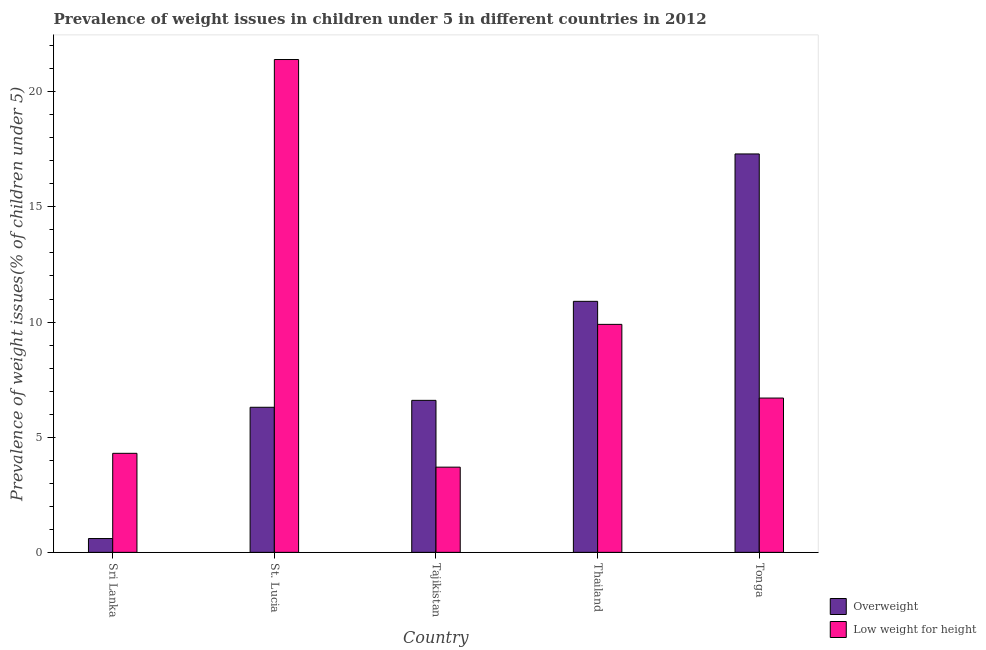Are the number of bars per tick equal to the number of legend labels?
Provide a succinct answer. Yes. Are the number of bars on each tick of the X-axis equal?
Ensure brevity in your answer.  Yes. How many bars are there on the 2nd tick from the right?
Provide a short and direct response. 2. What is the label of the 3rd group of bars from the left?
Your response must be concise. Tajikistan. In how many cases, is the number of bars for a given country not equal to the number of legend labels?
Keep it short and to the point. 0. What is the percentage of underweight children in St. Lucia?
Your response must be concise. 21.4. Across all countries, what is the maximum percentage of underweight children?
Provide a succinct answer. 21.4. Across all countries, what is the minimum percentage of overweight children?
Your answer should be compact. 0.6. In which country was the percentage of overweight children maximum?
Give a very brief answer. Tonga. In which country was the percentage of underweight children minimum?
Make the answer very short. Tajikistan. What is the total percentage of overweight children in the graph?
Make the answer very short. 41.7. What is the difference between the percentage of underweight children in Tajikistan and that in Thailand?
Offer a very short reply. -6.2. What is the difference between the percentage of overweight children in Tajikistan and the percentage of underweight children in Tonga?
Offer a terse response. -0.1. What is the average percentage of underweight children per country?
Your answer should be very brief. 9.2. What is the difference between the percentage of underweight children and percentage of overweight children in St. Lucia?
Give a very brief answer. 15.1. What is the ratio of the percentage of overweight children in St. Lucia to that in Tonga?
Your answer should be very brief. 0.36. Is the percentage of overweight children in Tajikistan less than that in Tonga?
Provide a succinct answer. Yes. What is the difference between the highest and the second highest percentage of overweight children?
Offer a terse response. 6.4. What is the difference between the highest and the lowest percentage of overweight children?
Keep it short and to the point. 16.7. In how many countries, is the percentage of underweight children greater than the average percentage of underweight children taken over all countries?
Offer a terse response. 2. What does the 1st bar from the left in St. Lucia represents?
Offer a terse response. Overweight. What does the 2nd bar from the right in Sri Lanka represents?
Give a very brief answer. Overweight. Are all the bars in the graph horizontal?
Your answer should be very brief. No. How many countries are there in the graph?
Provide a short and direct response. 5. What is the difference between two consecutive major ticks on the Y-axis?
Your answer should be very brief. 5. Are the values on the major ticks of Y-axis written in scientific E-notation?
Give a very brief answer. No. Does the graph contain grids?
Offer a terse response. No. How are the legend labels stacked?
Make the answer very short. Vertical. What is the title of the graph?
Your answer should be very brief. Prevalence of weight issues in children under 5 in different countries in 2012. What is the label or title of the Y-axis?
Make the answer very short. Prevalence of weight issues(% of children under 5). What is the Prevalence of weight issues(% of children under 5) of Overweight in Sri Lanka?
Keep it short and to the point. 0.6. What is the Prevalence of weight issues(% of children under 5) of Low weight for height in Sri Lanka?
Make the answer very short. 4.3. What is the Prevalence of weight issues(% of children under 5) of Overweight in St. Lucia?
Offer a terse response. 6.3. What is the Prevalence of weight issues(% of children under 5) in Low weight for height in St. Lucia?
Ensure brevity in your answer.  21.4. What is the Prevalence of weight issues(% of children under 5) in Overweight in Tajikistan?
Offer a terse response. 6.6. What is the Prevalence of weight issues(% of children under 5) of Low weight for height in Tajikistan?
Make the answer very short. 3.7. What is the Prevalence of weight issues(% of children under 5) of Overweight in Thailand?
Your answer should be compact. 10.9. What is the Prevalence of weight issues(% of children under 5) in Low weight for height in Thailand?
Give a very brief answer. 9.9. What is the Prevalence of weight issues(% of children under 5) in Overweight in Tonga?
Offer a terse response. 17.3. What is the Prevalence of weight issues(% of children under 5) in Low weight for height in Tonga?
Offer a very short reply. 6.7. Across all countries, what is the maximum Prevalence of weight issues(% of children under 5) in Overweight?
Your answer should be very brief. 17.3. Across all countries, what is the maximum Prevalence of weight issues(% of children under 5) of Low weight for height?
Your answer should be compact. 21.4. Across all countries, what is the minimum Prevalence of weight issues(% of children under 5) in Overweight?
Provide a short and direct response. 0.6. Across all countries, what is the minimum Prevalence of weight issues(% of children under 5) in Low weight for height?
Offer a terse response. 3.7. What is the total Prevalence of weight issues(% of children under 5) in Overweight in the graph?
Give a very brief answer. 41.7. What is the difference between the Prevalence of weight issues(% of children under 5) in Overweight in Sri Lanka and that in St. Lucia?
Offer a very short reply. -5.7. What is the difference between the Prevalence of weight issues(% of children under 5) of Low weight for height in Sri Lanka and that in St. Lucia?
Offer a very short reply. -17.1. What is the difference between the Prevalence of weight issues(% of children under 5) in Overweight in Sri Lanka and that in Tajikistan?
Give a very brief answer. -6. What is the difference between the Prevalence of weight issues(% of children under 5) in Low weight for height in Sri Lanka and that in Tajikistan?
Offer a terse response. 0.6. What is the difference between the Prevalence of weight issues(% of children under 5) of Overweight in Sri Lanka and that in Tonga?
Your answer should be compact. -16.7. What is the difference between the Prevalence of weight issues(% of children under 5) in Low weight for height in St. Lucia and that in Tajikistan?
Offer a very short reply. 17.7. What is the difference between the Prevalence of weight issues(% of children under 5) in Overweight in Tajikistan and that in Thailand?
Offer a very short reply. -4.3. What is the difference between the Prevalence of weight issues(% of children under 5) of Low weight for height in Thailand and that in Tonga?
Your response must be concise. 3.2. What is the difference between the Prevalence of weight issues(% of children under 5) of Overweight in Sri Lanka and the Prevalence of weight issues(% of children under 5) of Low weight for height in St. Lucia?
Make the answer very short. -20.8. What is the difference between the Prevalence of weight issues(% of children under 5) in Overweight in Sri Lanka and the Prevalence of weight issues(% of children under 5) in Low weight for height in Thailand?
Your answer should be very brief. -9.3. What is the difference between the Prevalence of weight issues(% of children under 5) of Overweight in St. Lucia and the Prevalence of weight issues(% of children under 5) of Low weight for height in Thailand?
Provide a short and direct response. -3.6. What is the difference between the Prevalence of weight issues(% of children under 5) of Overweight in Tajikistan and the Prevalence of weight issues(% of children under 5) of Low weight for height in Thailand?
Offer a terse response. -3.3. What is the difference between the Prevalence of weight issues(% of children under 5) of Overweight in Thailand and the Prevalence of weight issues(% of children under 5) of Low weight for height in Tonga?
Provide a succinct answer. 4.2. What is the average Prevalence of weight issues(% of children under 5) in Overweight per country?
Your response must be concise. 8.34. What is the difference between the Prevalence of weight issues(% of children under 5) in Overweight and Prevalence of weight issues(% of children under 5) in Low weight for height in St. Lucia?
Give a very brief answer. -15.1. What is the difference between the Prevalence of weight issues(% of children under 5) of Overweight and Prevalence of weight issues(% of children under 5) of Low weight for height in Thailand?
Offer a very short reply. 1. What is the difference between the Prevalence of weight issues(% of children under 5) of Overweight and Prevalence of weight issues(% of children under 5) of Low weight for height in Tonga?
Your answer should be compact. 10.6. What is the ratio of the Prevalence of weight issues(% of children under 5) in Overweight in Sri Lanka to that in St. Lucia?
Make the answer very short. 0.1. What is the ratio of the Prevalence of weight issues(% of children under 5) in Low weight for height in Sri Lanka to that in St. Lucia?
Offer a terse response. 0.2. What is the ratio of the Prevalence of weight issues(% of children under 5) of Overweight in Sri Lanka to that in Tajikistan?
Provide a succinct answer. 0.09. What is the ratio of the Prevalence of weight issues(% of children under 5) of Low weight for height in Sri Lanka to that in Tajikistan?
Provide a short and direct response. 1.16. What is the ratio of the Prevalence of weight issues(% of children under 5) of Overweight in Sri Lanka to that in Thailand?
Your response must be concise. 0.06. What is the ratio of the Prevalence of weight issues(% of children under 5) of Low weight for height in Sri Lanka to that in Thailand?
Offer a terse response. 0.43. What is the ratio of the Prevalence of weight issues(% of children under 5) in Overweight in Sri Lanka to that in Tonga?
Provide a succinct answer. 0.03. What is the ratio of the Prevalence of weight issues(% of children under 5) of Low weight for height in Sri Lanka to that in Tonga?
Ensure brevity in your answer.  0.64. What is the ratio of the Prevalence of weight issues(% of children under 5) in Overweight in St. Lucia to that in Tajikistan?
Provide a succinct answer. 0.95. What is the ratio of the Prevalence of weight issues(% of children under 5) of Low weight for height in St. Lucia to that in Tajikistan?
Offer a terse response. 5.78. What is the ratio of the Prevalence of weight issues(% of children under 5) of Overweight in St. Lucia to that in Thailand?
Keep it short and to the point. 0.58. What is the ratio of the Prevalence of weight issues(% of children under 5) of Low weight for height in St. Lucia to that in Thailand?
Your response must be concise. 2.16. What is the ratio of the Prevalence of weight issues(% of children under 5) of Overweight in St. Lucia to that in Tonga?
Make the answer very short. 0.36. What is the ratio of the Prevalence of weight issues(% of children under 5) in Low weight for height in St. Lucia to that in Tonga?
Provide a succinct answer. 3.19. What is the ratio of the Prevalence of weight issues(% of children under 5) of Overweight in Tajikistan to that in Thailand?
Provide a succinct answer. 0.61. What is the ratio of the Prevalence of weight issues(% of children under 5) in Low weight for height in Tajikistan to that in Thailand?
Your answer should be very brief. 0.37. What is the ratio of the Prevalence of weight issues(% of children under 5) in Overweight in Tajikistan to that in Tonga?
Give a very brief answer. 0.38. What is the ratio of the Prevalence of weight issues(% of children under 5) of Low weight for height in Tajikistan to that in Tonga?
Your answer should be very brief. 0.55. What is the ratio of the Prevalence of weight issues(% of children under 5) of Overweight in Thailand to that in Tonga?
Your answer should be compact. 0.63. What is the ratio of the Prevalence of weight issues(% of children under 5) of Low weight for height in Thailand to that in Tonga?
Provide a succinct answer. 1.48. What is the difference between the highest and the second highest Prevalence of weight issues(% of children under 5) in Overweight?
Make the answer very short. 6.4. What is the difference between the highest and the lowest Prevalence of weight issues(% of children under 5) of Low weight for height?
Your answer should be very brief. 17.7. 